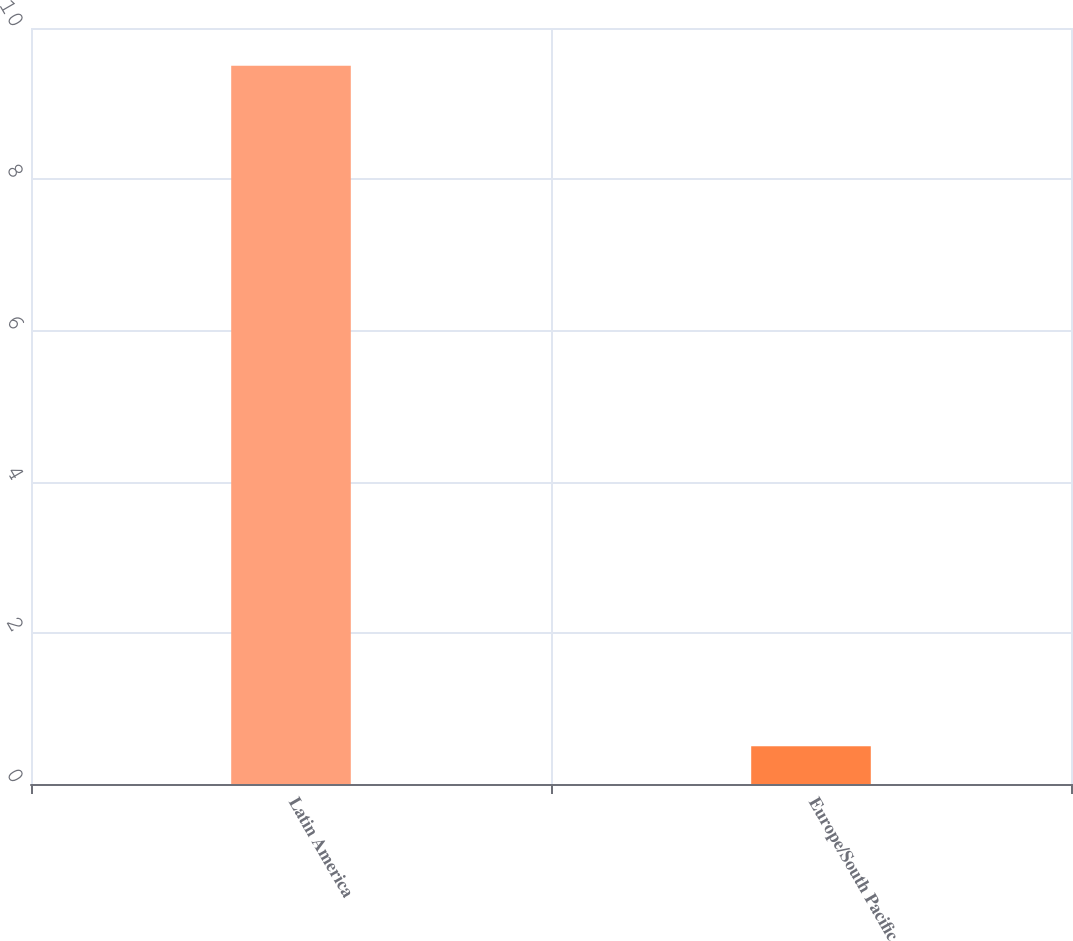Convert chart to OTSL. <chart><loc_0><loc_0><loc_500><loc_500><bar_chart><fcel>Latin America<fcel>Europe/South Pacific<nl><fcel>9.5<fcel>0.5<nl></chart> 